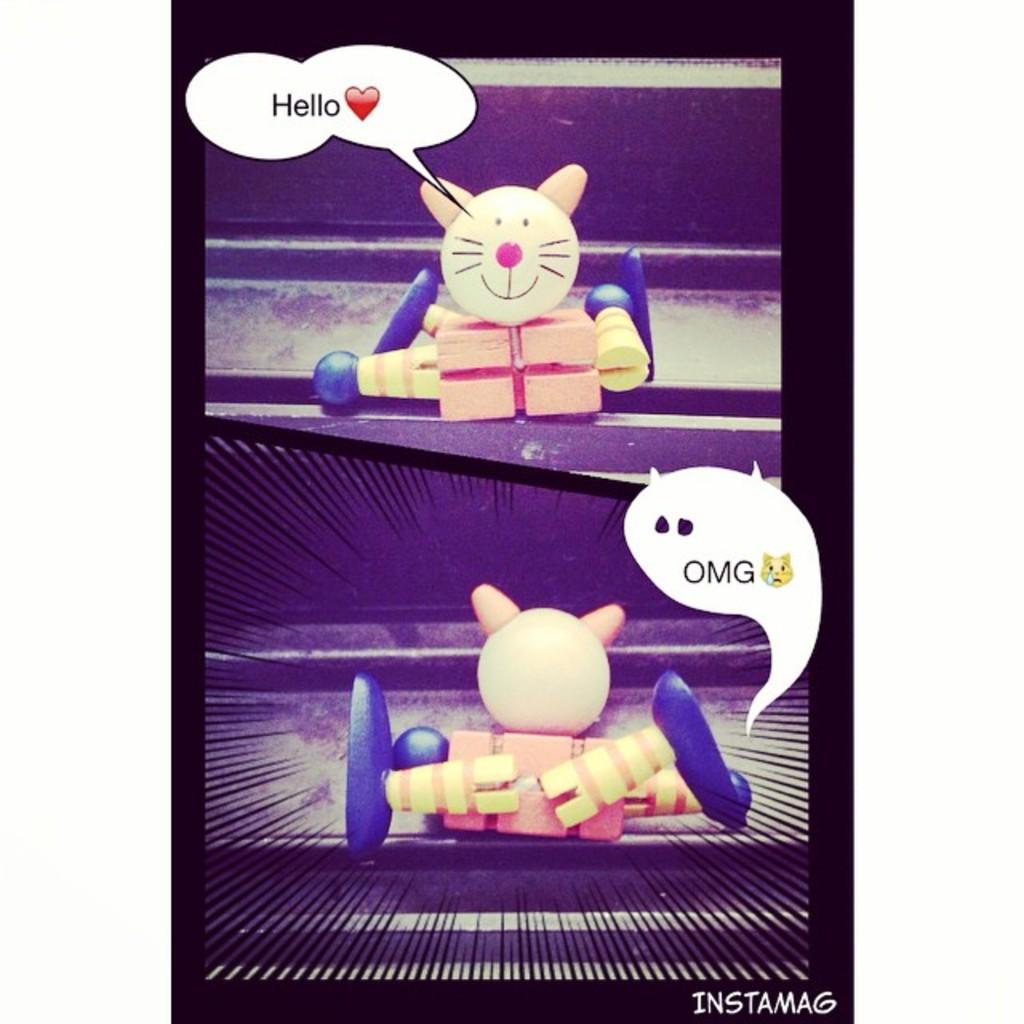Can you describe this image briefly? This is an edited image. We can see toys, emojis and words. 